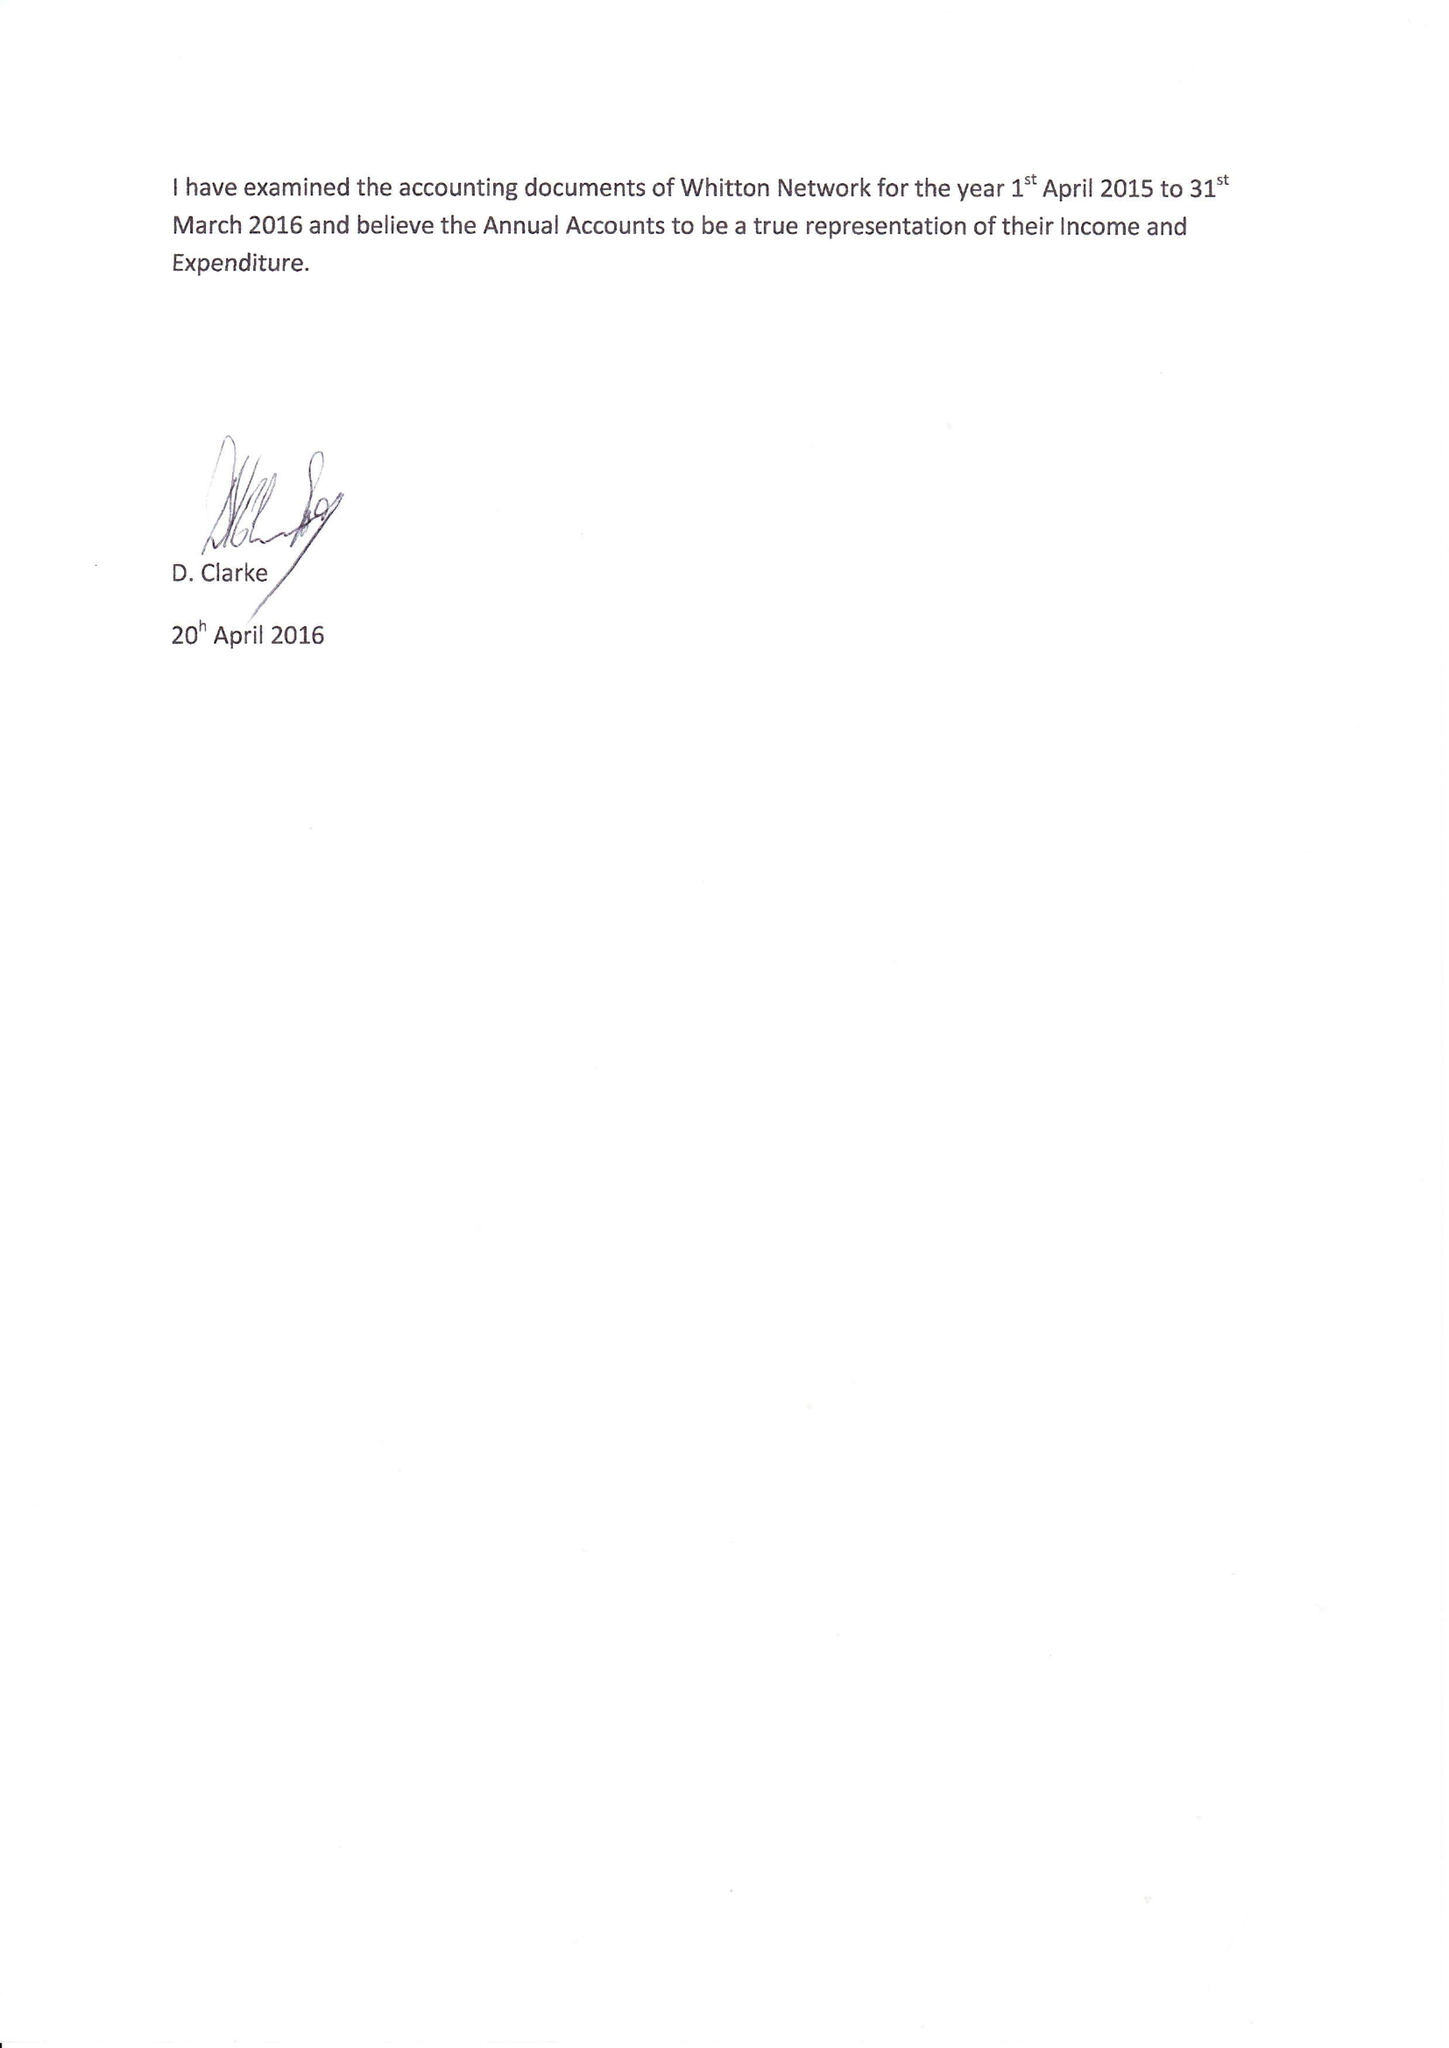What is the value for the charity_name?
Answer the question using a single word or phrase. Whitton Network 